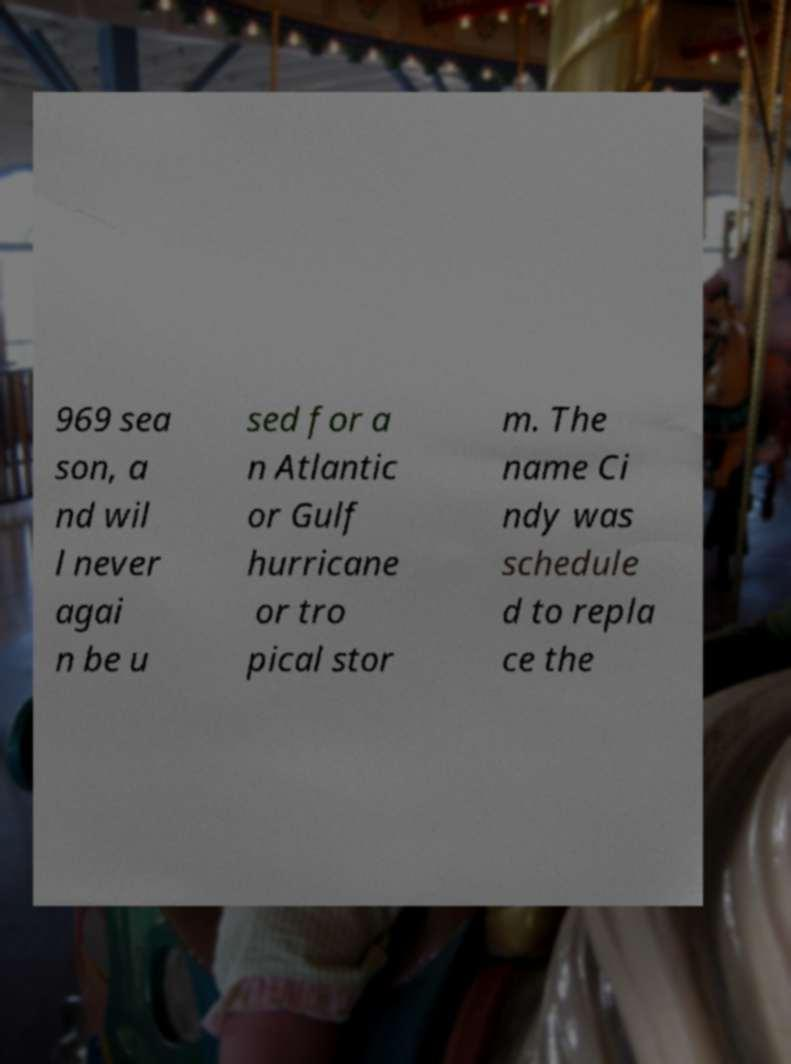Please identify and transcribe the text found in this image. 969 sea son, a nd wil l never agai n be u sed for a n Atlantic or Gulf hurricane or tro pical stor m. The name Ci ndy was schedule d to repla ce the 